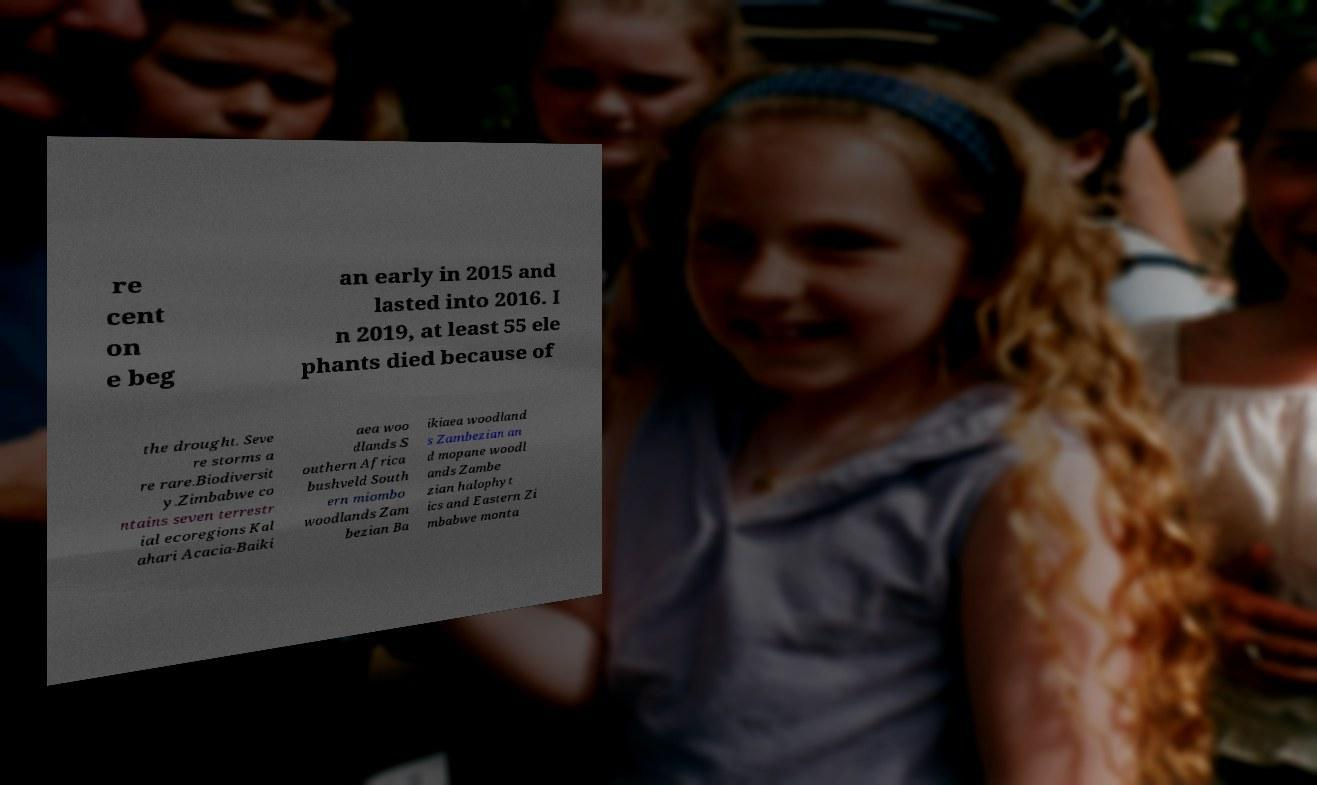For documentation purposes, I need the text within this image transcribed. Could you provide that? re cent on e beg an early in 2015 and lasted into 2016. I n 2019, at least 55 ele phants died because of the drought. Seve re storms a re rare.Biodiversit y.Zimbabwe co ntains seven terrestr ial ecoregions Kal ahari Acacia-Baiki aea woo dlands S outhern Africa bushveld South ern miombo woodlands Zam bezian Ba ikiaea woodland s Zambezian an d mopane woodl ands Zambe zian halophyt ics and Eastern Zi mbabwe monta 